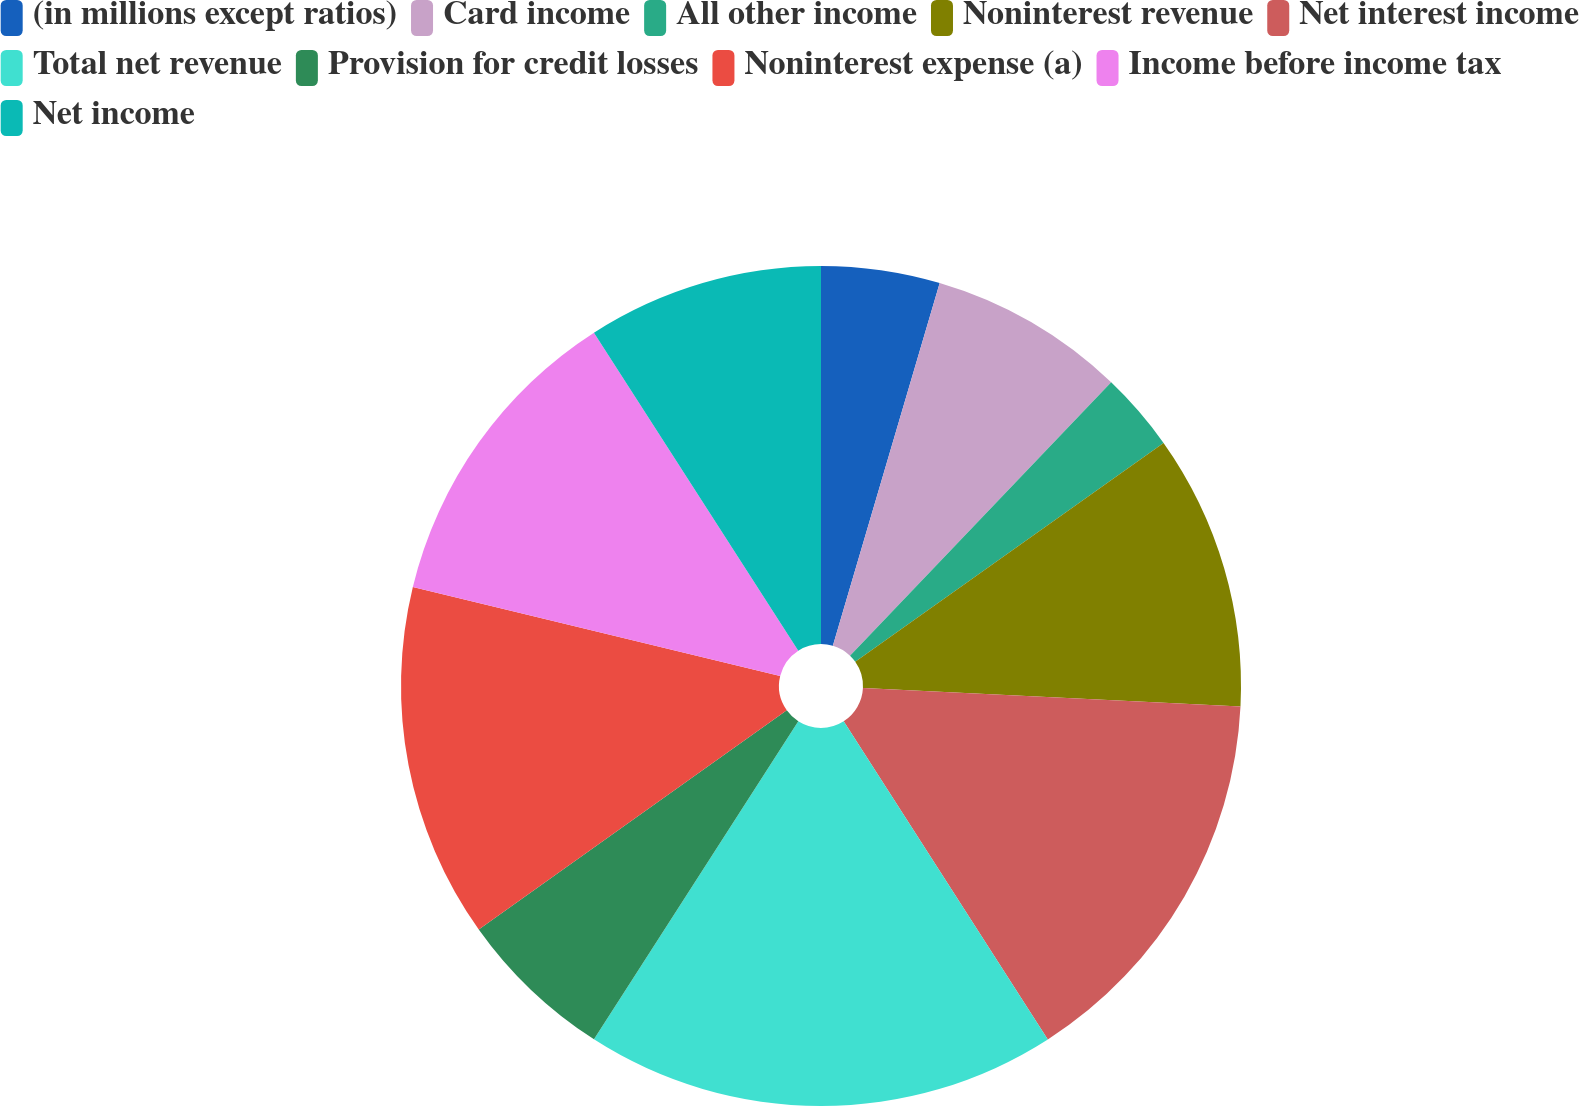Convert chart to OTSL. <chart><loc_0><loc_0><loc_500><loc_500><pie_chart><fcel>(in millions except ratios)<fcel>Card income<fcel>All other income<fcel>Noninterest revenue<fcel>Net interest income<fcel>Total net revenue<fcel>Provision for credit losses<fcel>Noninterest expense (a)<fcel>Income before income tax<fcel>Net income<nl><fcel>4.56%<fcel>7.58%<fcel>3.04%<fcel>10.6%<fcel>15.14%<fcel>18.17%<fcel>6.07%<fcel>13.63%<fcel>12.12%<fcel>9.09%<nl></chart> 